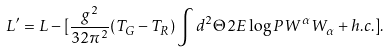Convert formula to latex. <formula><loc_0><loc_0><loc_500><loc_500>L ^ { \prime } = L - [ \frac { g ^ { 2 } } { 3 2 \pi ^ { 2 } } ( T _ { G } - T _ { R } ) \int d ^ { 2 } \Theta 2 E \log P W ^ { \alpha } W _ { \alpha } + h . c . ] .</formula> 